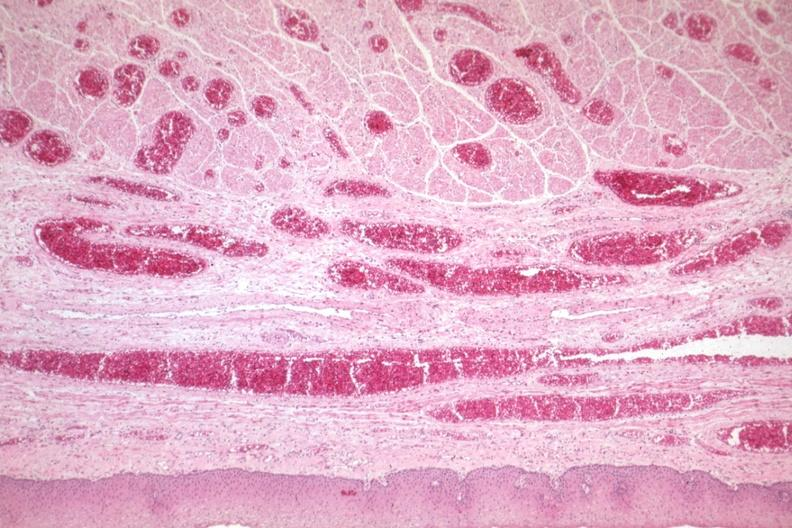where is this from?
Answer the question using a single word or phrase. Gastrointestinal system 